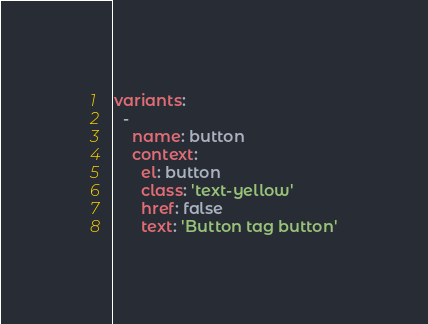Convert code to text. <code><loc_0><loc_0><loc_500><loc_500><_YAML_>
variants:
  -
    name: button
    context:
      el: button
      class: 'text-yellow'
      href: false
      text: 'Button tag button'
</code> 